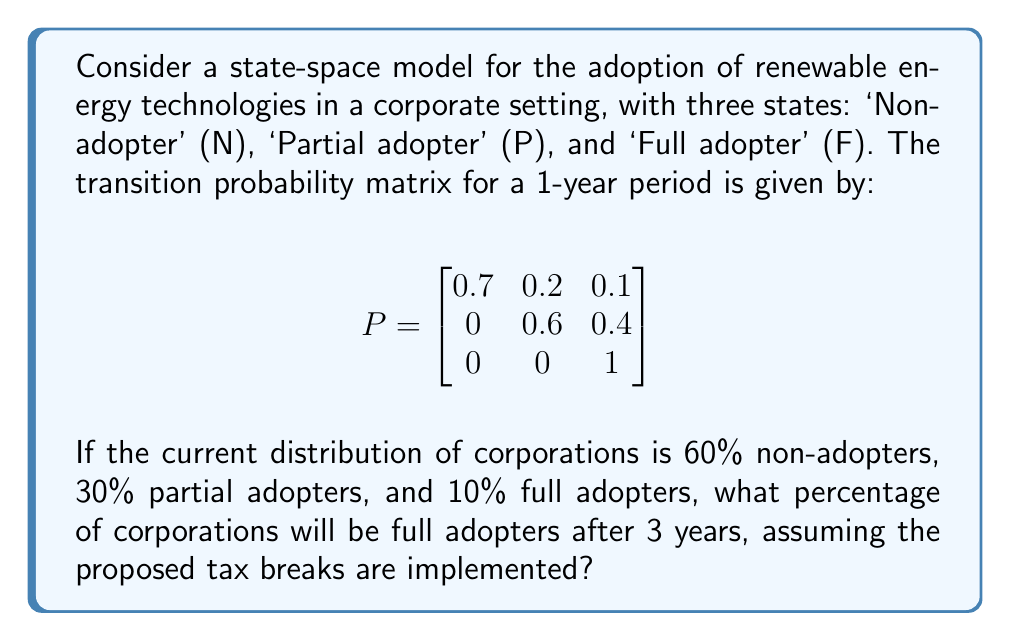What is the answer to this math problem? To solve this problem, we need to use the Chapman-Kolmogorov equations and matrix multiplication. Let's approach this step-by-step:

1) First, let's define our initial state vector:
   $$\pi_0 = [0.6, 0.3, 0.1]$$

2) We need to find $\pi_3 = \pi_0 P^3$, where $P^3$ is the transition matrix raised to the power of 3.

3) To calculate $P^3$, we need to multiply P by itself three times:

   $P^2 = P \times P = \begin{bmatrix}
   0.49 & 0.26 & 0.25 \\
   0 & 0.36 & 0.64 \\
   0 & 0 & 1
   \end{bmatrix}$

   $P^3 = P^2 \times P = \begin{bmatrix}
   0.343 & 0.238 & 0.419 \\
   0 & 0.216 & 0.784 \\
   0 & 0 & 1
   \end{bmatrix}$

4) Now, we can multiply our initial state vector by $P^3$:

   $\pi_3 = \pi_0 P^3 = [0.6, 0.3, 0.1] \times \begin{bmatrix}
   0.343 & 0.238 & 0.419 \\
   0 & 0.216 & 0.784 \\
   0 & 0 & 1
   \end{bmatrix}$

5) Performing this multiplication:

   $\pi_3 = [0.2058, 0.2078, 0.5864]$

6) The last element of this vector represents the proportion of full adopters after 3 years.

7) Converting to a percentage: $0.5864 \times 100\% = 58.64\%$
Answer: 58.64% 